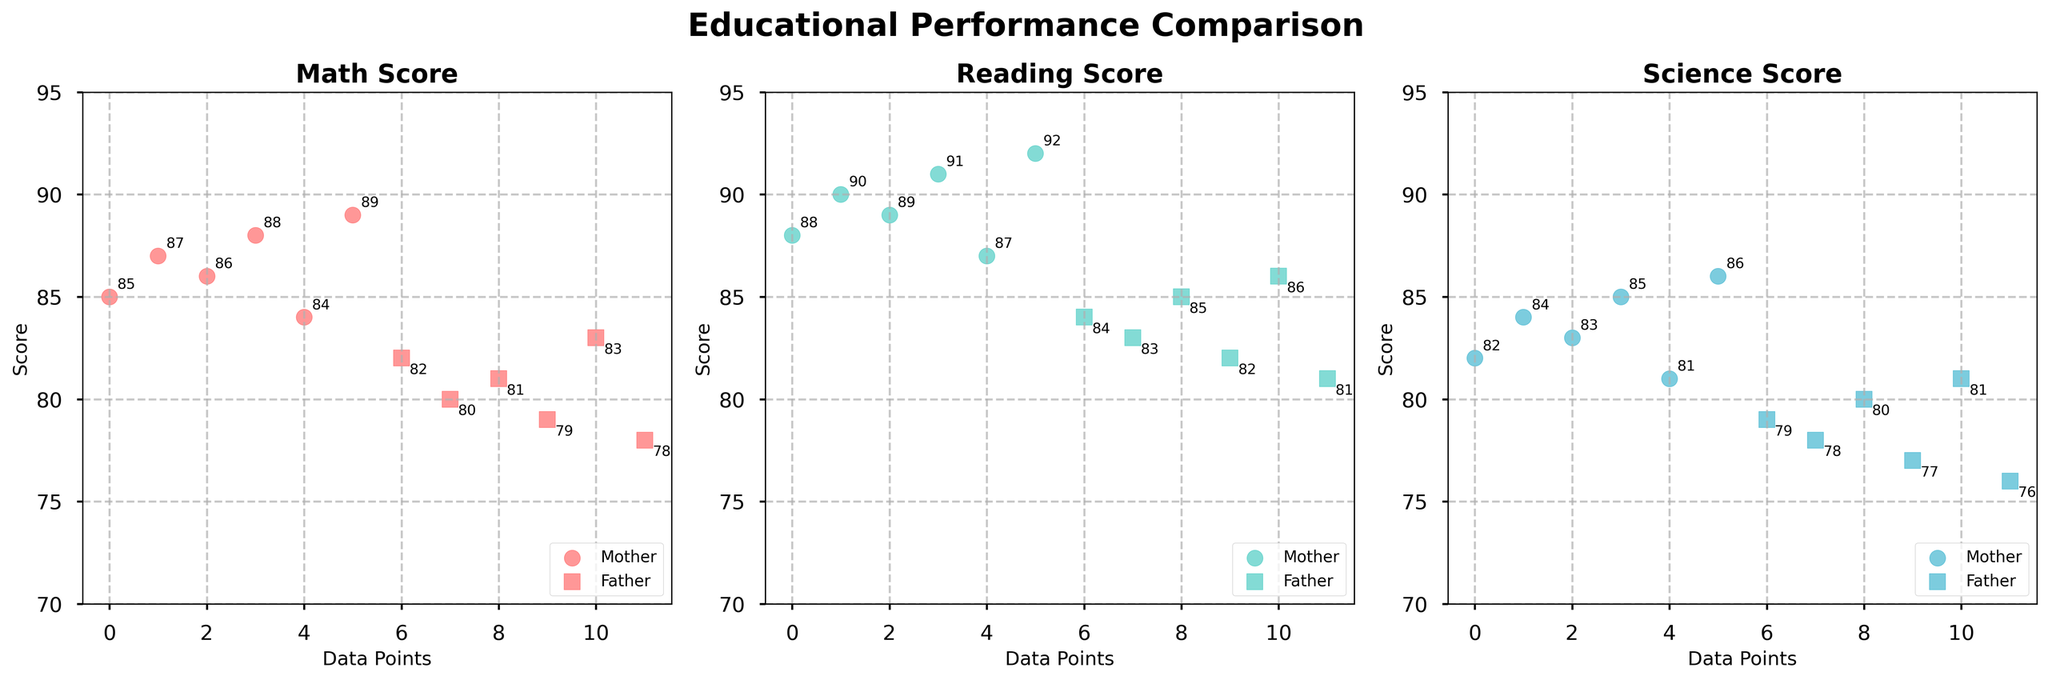What's the average Math score for children living with the mother? To find the average, first sum the Math scores for the mother, which gives 85 + 87 + 86 + 88 + 84 + 89 = 519. Then divide by the number of data points, which is 6. The calculation is 519 / 6.
Answer: 86.5 Comparing Math scores, who has the higher maximum score, Mother or Father? The maximum Math score for the mother is 89, and for the father is 83. Clearly, the mother has the higher maximum score.
Answer: Mother What's the difference between the average Reading scores for children living with the mother and the father? First, calculate the average Reading score for children living with the mother: (88 + 90 + 89 + 91 + 87 + 92) / 6 = 537 / 6 = 89.5. Next, calculate the average for the father: (84 + 83 + 85 + 82 + 86 + 81) / 6 = 501 / 6 = 83.5. The difference is 89.5 - 83.5.
Answer: 6 Which parent exhibits the lowest Science score for children, and what is that score? For the mother, the lowest Science score is 81. For the father, the lowest score is 76. Therefore, the father exhibits the lowest score, which is 76.
Answer: Father, 76 On the Reading score axis, which data point has the highest score, and with which parent is it associated? The highest Reading score is 92, which is associated with the mother.
Answer: Mother, 92 How many data points have a Math score greater than 80 for each parent? For the mother, all data points have a Math score greater than 80 (85, 87, 86, 88, 84, 89). For the father, it's 4 out of 6 data points (82, 81, 83).
Answer: Mother: 6, Father: 4 What's the range (difference between maximum and minimum) of Science scores for children living with the father? The maximum Science score for the father is 81, and the minimum is 76. The range is 81 - 76.
Answer: 5 On average, who has better Science scores, children living with the mother or the father? Calculate the average Science score for the mother: (82 + 84 + 83 + 85 + 81 + 86) / 6 = 501 / 6 = 83.5. For the father: (79 + 78 + 80 + 77 + 81 + 76) / 6 = 471 / 6 = 78.5. Clearly, the mother has a better average.
Answer: Mother Comparing the Math scores, what's the score difference between the highest-scoring child living with the mother and the lowest-scoring child living with the father? The highest Math score for the mother is 89, and the lowest for the father is 78. The difference is 89 - 78.
Answer: 11 